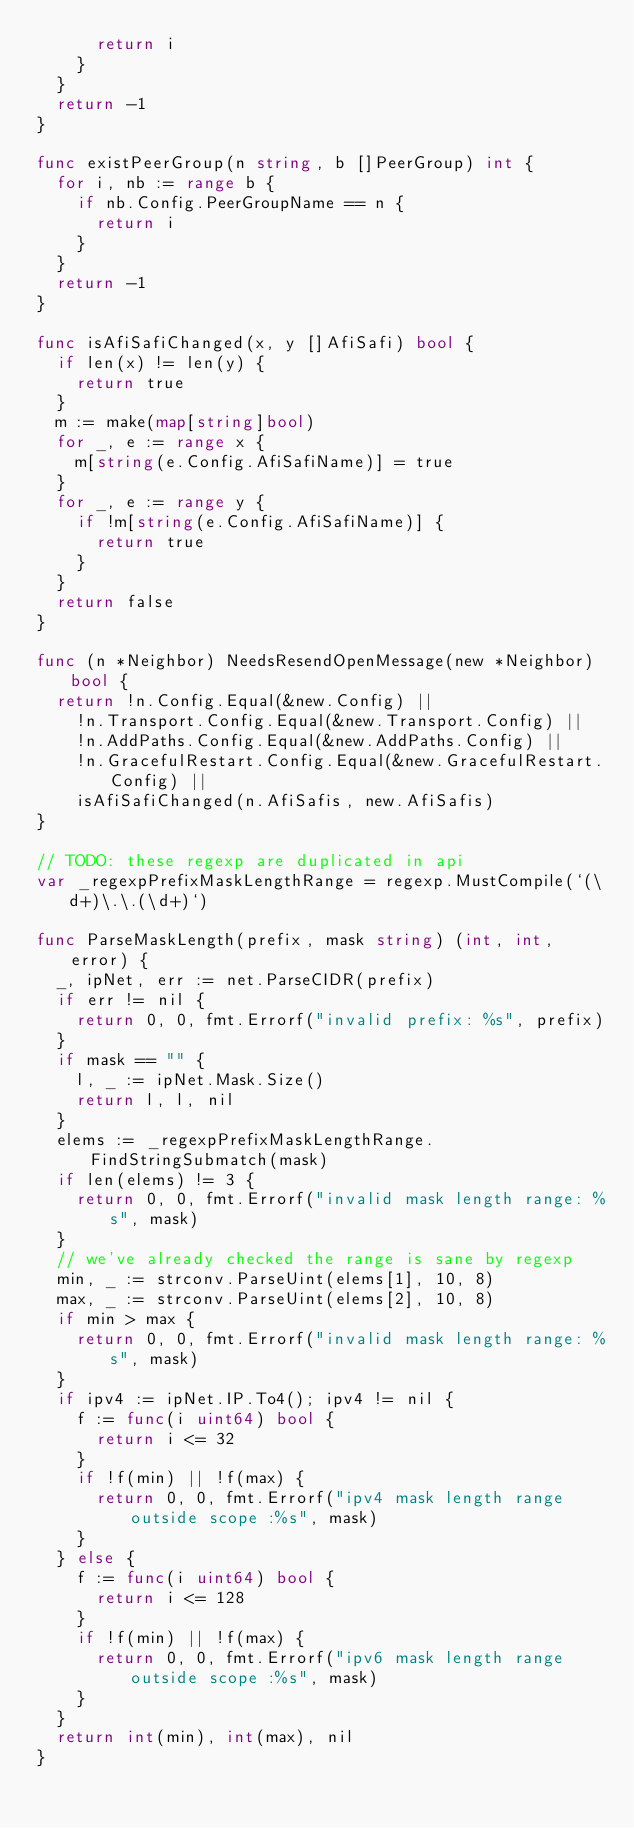Convert code to text. <code><loc_0><loc_0><loc_500><loc_500><_Go_>			return i
		}
	}
	return -1
}

func existPeerGroup(n string, b []PeerGroup) int {
	for i, nb := range b {
		if nb.Config.PeerGroupName == n {
			return i
		}
	}
	return -1
}

func isAfiSafiChanged(x, y []AfiSafi) bool {
	if len(x) != len(y) {
		return true
	}
	m := make(map[string]bool)
	for _, e := range x {
		m[string(e.Config.AfiSafiName)] = true
	}
	for _, e := range y {
		if !m[string(e.Config.AfiSafiName)] {
			return true
		}
	}
	return false
}

func (n *Neighbor) NeedsResendOpenMessage(new *Neighbor) bool {
	return !n.Config.Equal(&new.Config) ||
		!n.Transport.Config.Equal(&new.Transport.Config) ||
		!n.AddPaths.Config.Equal(&new.AddPaths.Config) ||
		!n.GracefulRestart.Config.Equal(&new.GracefulRestart.Config) ||
		isAfiSafiChanged(n.AfiSafis, new.AfiSafis)
}

// TODO: these regexp are duplicated in api
var _regexpPrefixMaskLengthRange = regexp.MustCompile(`(\d+)\.\.(\d+)`)

func ParseMaskLength(prefix, mask string) (int, int, error) {
	_, ipNet, err := net.ParseCIDR(prefix)
	if err != nil {
		return 0, 0, fmt.Errorf("invalid prefix: %s", prefix)
	}
	if mask == "" {
		l, _ := ipNet.Mask.Size()
		return l, l, nil
	}
	elems := _regexpPrefixMaskLengthRange.FindStringSubmatch(mask)
	if len(elems) != 3 {
		return 0, 0, fmt.Errorf("invalid mask length range: %s", mask)
	}
	// we've already checked the range is sane by regexp
	min, _ := strconv.ParseUint(elems[1], 10, 8)
	max, _ := strconv.ParseUint(elems[2], 10, 8)
	if min > max {
		return 0, 0, fmt.Errorf("invalid mask length range: %s", mask)
	}
	if ipv4 := ipNet.IP.To4(); ipv4 != nil {
		f := func(i uint64) bool {
			return i <= 32
		}
		if !f(min) || !f(max) {
			return 0, 0, fmt.Errorf("ipv4 mask length range outside scope :%s", mask)
		}
	} else {
		f := func(i uint64) bool {
			return i <= 128
		}
		if !f(min) || !f(max) {
			return 0, 0, fmt.Errorf("ipv6 mask length range outside scope :%s", mask)
		}
	}
	return int(min), int(max), nil
}
</code> 